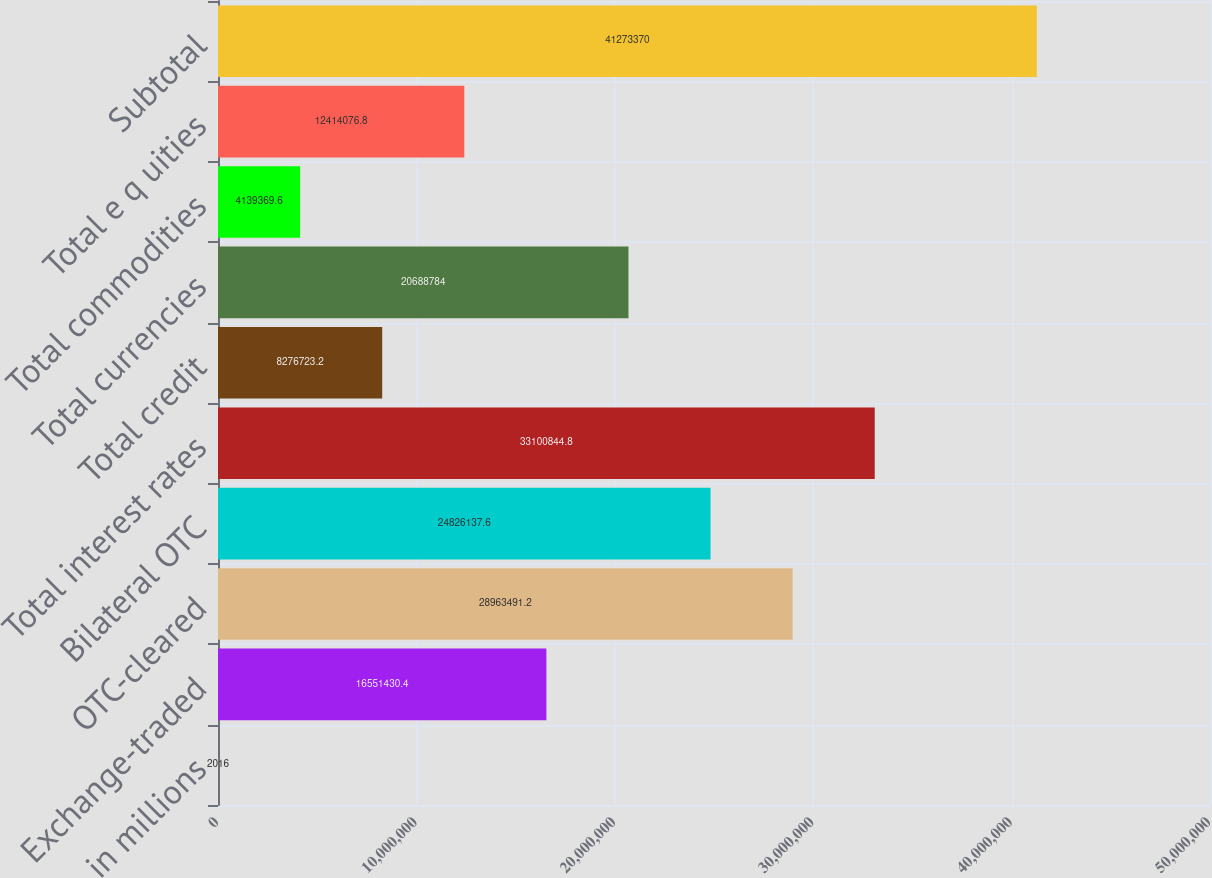<chart> <loc_0><loc_0><loc_500><loc_500><bar_chart><fcel>in millions<fcel>Exchange-traded<fcel>OTC-cleared<fcel>Bilateral OTC<fcel>Total interest rates<fcel>Total credit<fcel>Total currencies<fcel>Total commodities<fcel>Total e q uities<fcel>Subtotal<nl><fcel>2016<fcel>1.65514e+07<fcel>2.89635e+07<fcel>2.48261e+07<fcel>3.31008e+07<fcel>8.27672e+06<fcel>2.06888e+07<fcel>4.13937e+06<fcel>1.24141e+07<fcel>4.12734e+07<nl></chart> 